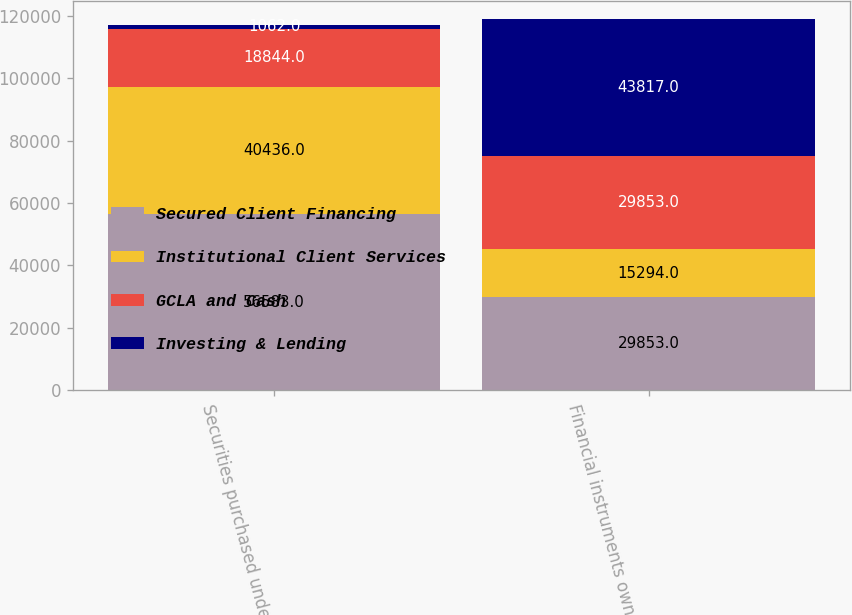<chart> <loc_0><loc_0><loc_500><loc_500><stacked_bar_chart><ecel><fcel>Securities purchased under<fcel>Financial instruments owned at<nl><fcel>Secured Client Financing<fcel>56583<fcel>29853<nl><fcel>Institutional Client Services<fcel>40436<fcel>15294<nl><fcel>GCLA and Cash<fcel>18844<fcel>29853<nl><fcel>Investing & Lending<fcel>1062<fcel>43817<nl></chart> 